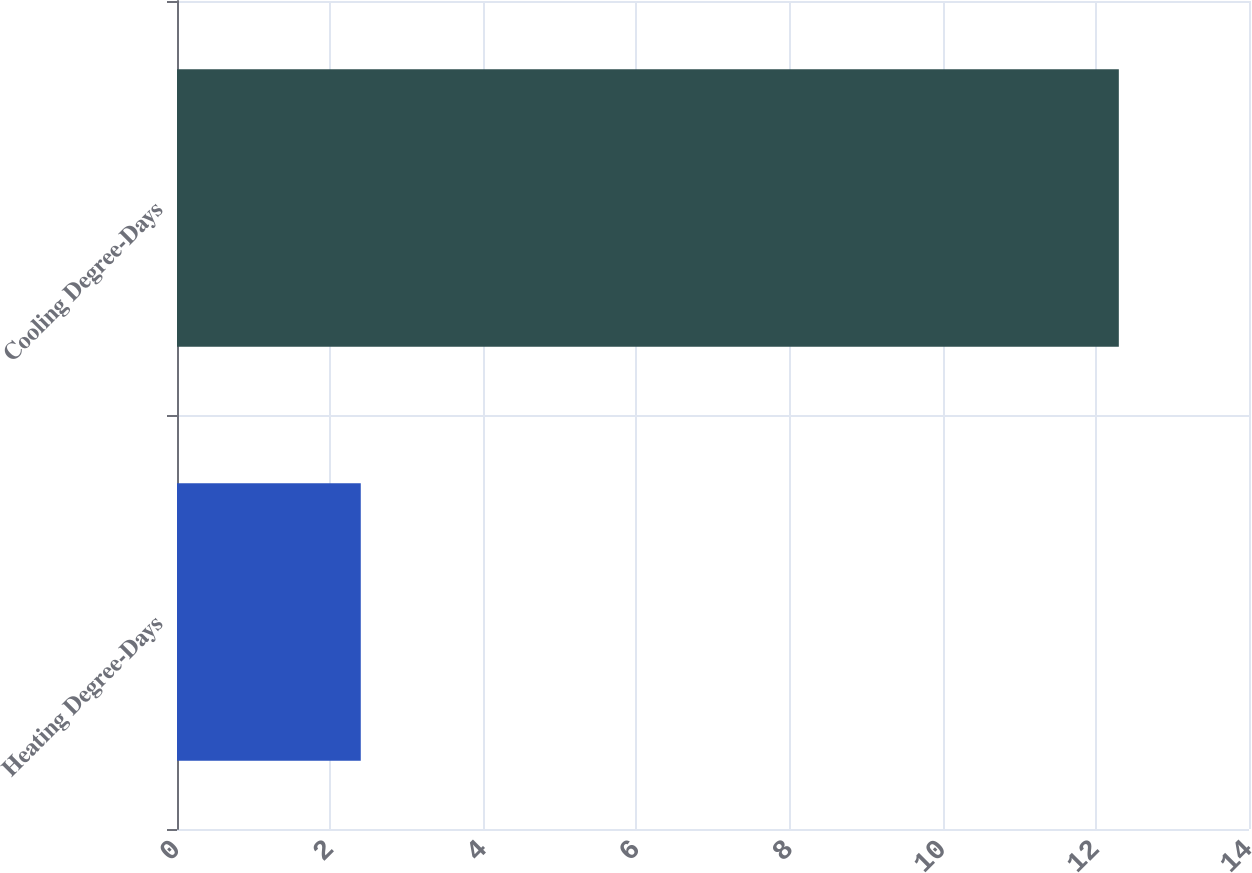Convert chart. <chart><loc_0><loc_0><loc_500><loc_500><bar_chart><fcel>Heating Degree-Days<fcel>Cooling Degree-Days<nl><fcel>2.4<fcel>12.3<nl></chart> 